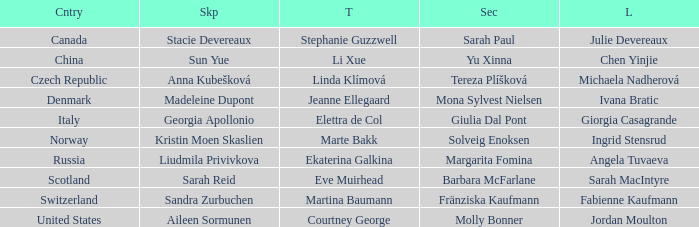What skip has denmark as the country? Madeleine Dupont. 